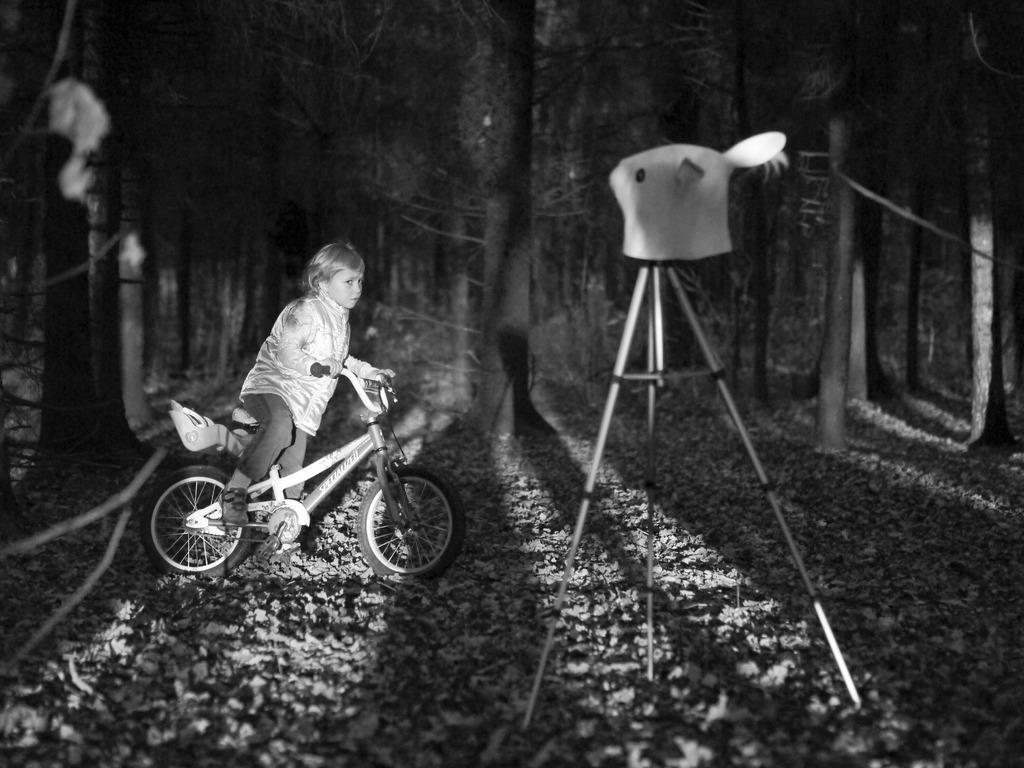Describe this image in one or two sentences. This is a black and white image. There are trees on the top and stones in the bottom. There is a camera stand in the middle and there is a bicycle. A kid is sitting on the bicycle. 